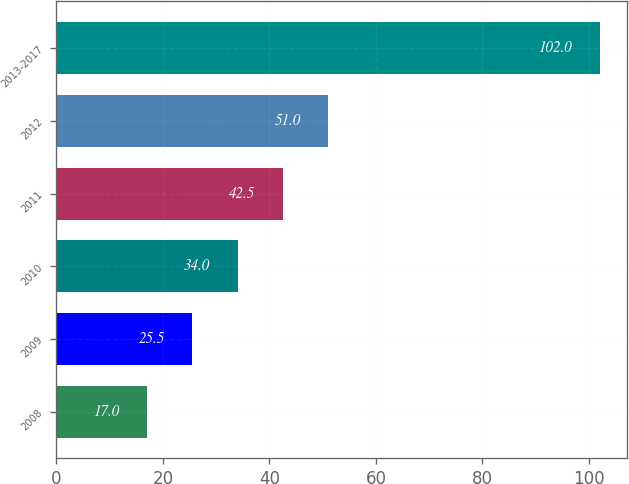<chart> <loc_0><loc_0><loc_500><loc_500><bar_chart><fcel>2008<fcel>2009<fcel>2010<fcel>2011<fcel>2012<fcel>2013-2017<nl><fcel>17<fcel>25.5<fcel>34<fcel>42.5<fcel>51<fcel>102<nl></chart> 